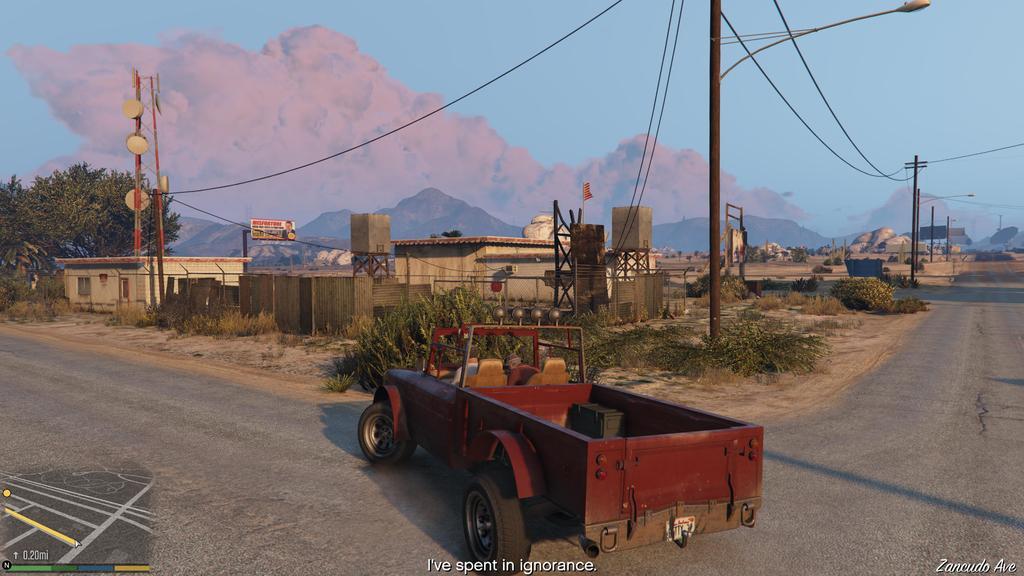How would you summarize this image in a sentence or two? In this image I can see few houses, windows, current poles, wires, light poles, tower, mountains, trees, sky and the vehicle is on the road. 